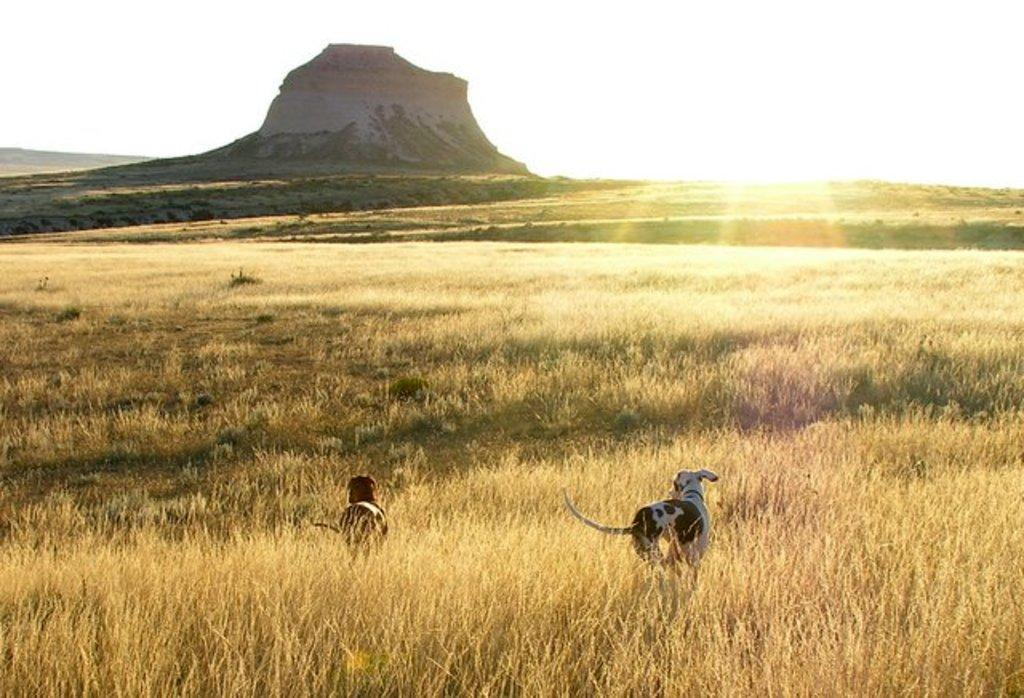What animals are present in the image? There are two dogs on a grassy land in the image. Where are the dogs located in the image? The dogs are at the bottom of the image. What geographical feature can be seen at the top of the image? There is a mountain at the top of the image. What part of the natural environment is visible in the background of the image? The sky is visible in the background of the image. What type of boot is the dog wearing in the image? There are no boots present in the image; the dogs are not wearing any footwear. 